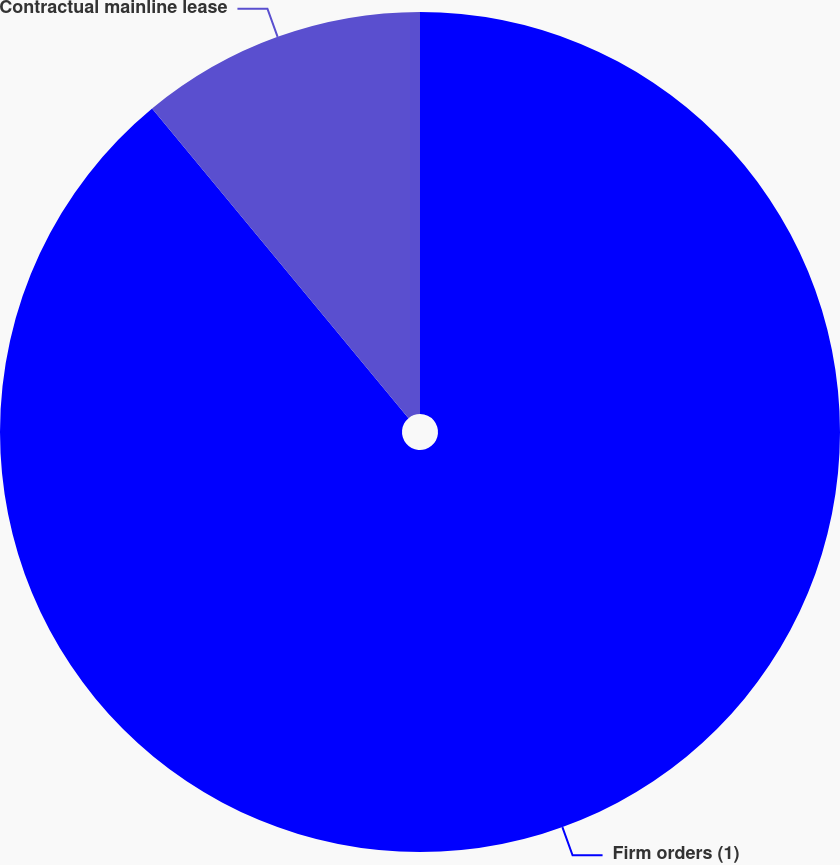Convert chart. <chart><loc_0><loc_0><loc_500><loc_500><pie_chart><fcel>Firm orders (1)<fcel>Contractual mainline lease<nl><fcel>88.99%<fcel>11.01%<nl></chart> 